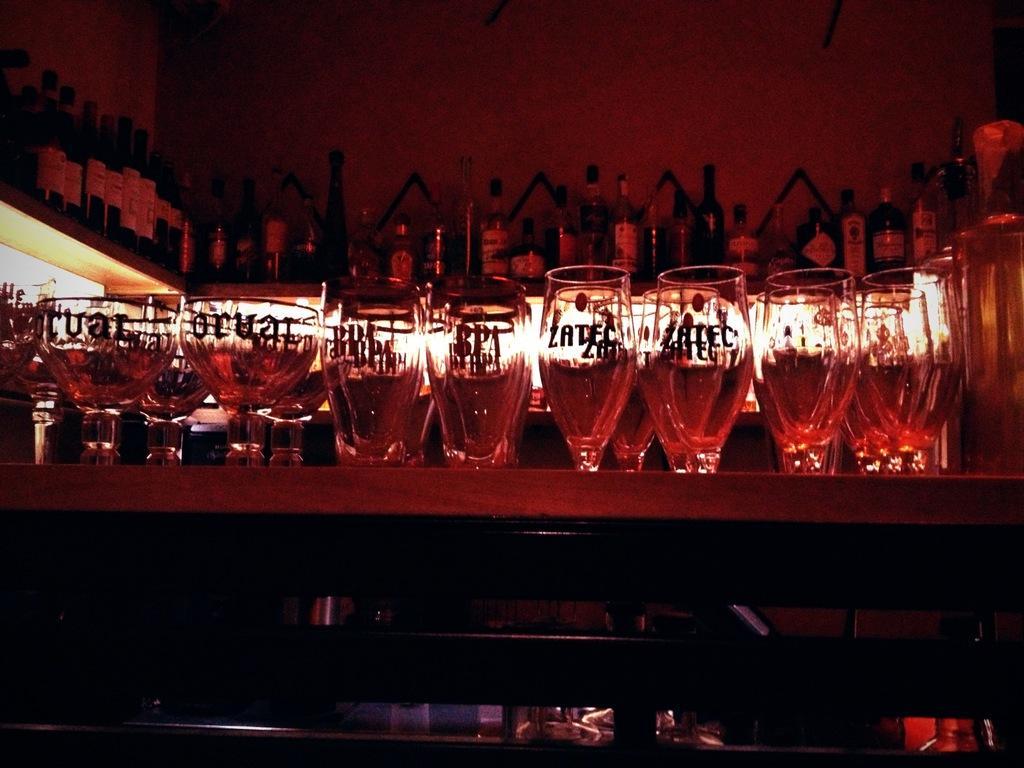Could you give a brief overview of what you see in this image? In this image we can see group of glasses placed on the table. In the background, we can see some bottles placed on the rack and some lights. 